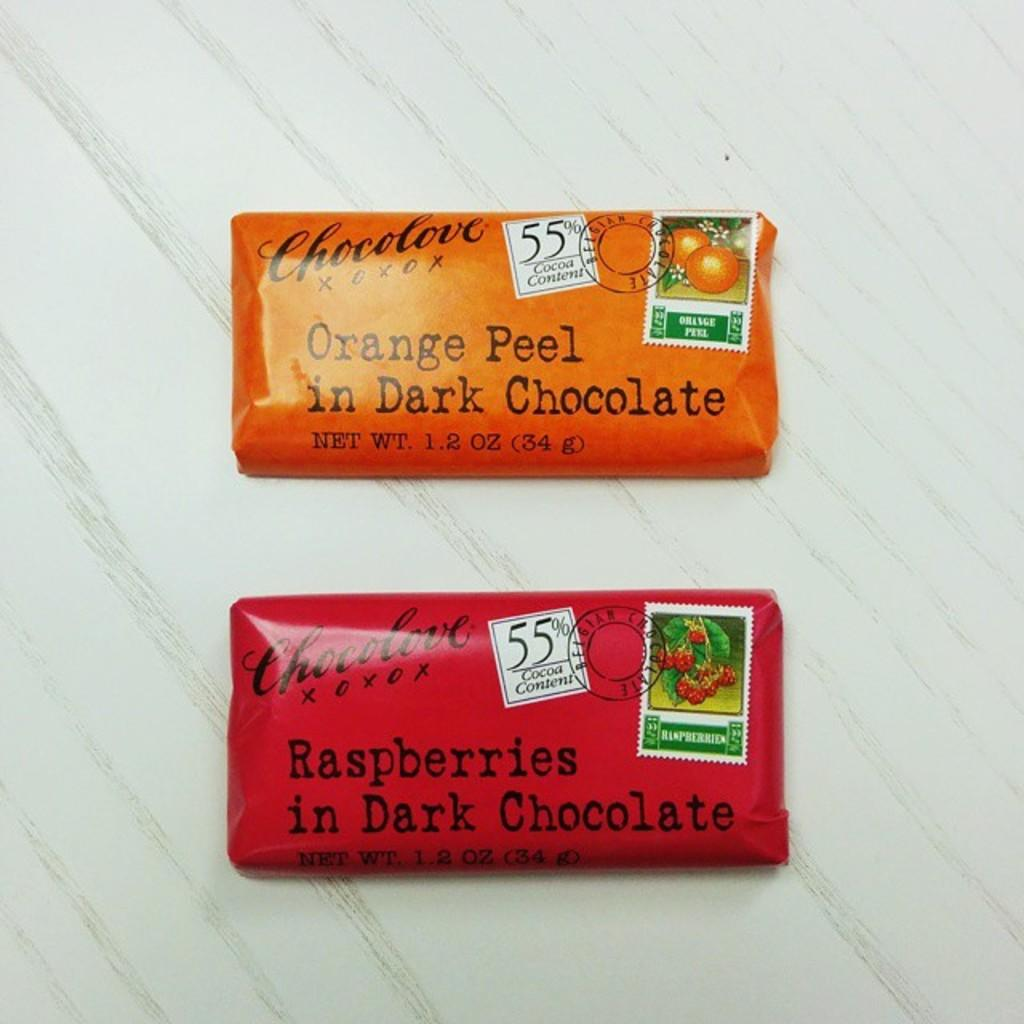Provide a one-sentence caption for the provided image. two Chocolove brand dark chocolates are sitting on a table. 